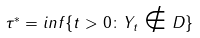Convert formula to latex. <formula><loc_0><loc_0><loc_500><loc_500>\tau ^ { * } = i n f \{ t > 0 \colon Y _ { t } \notin D \}</formula> 